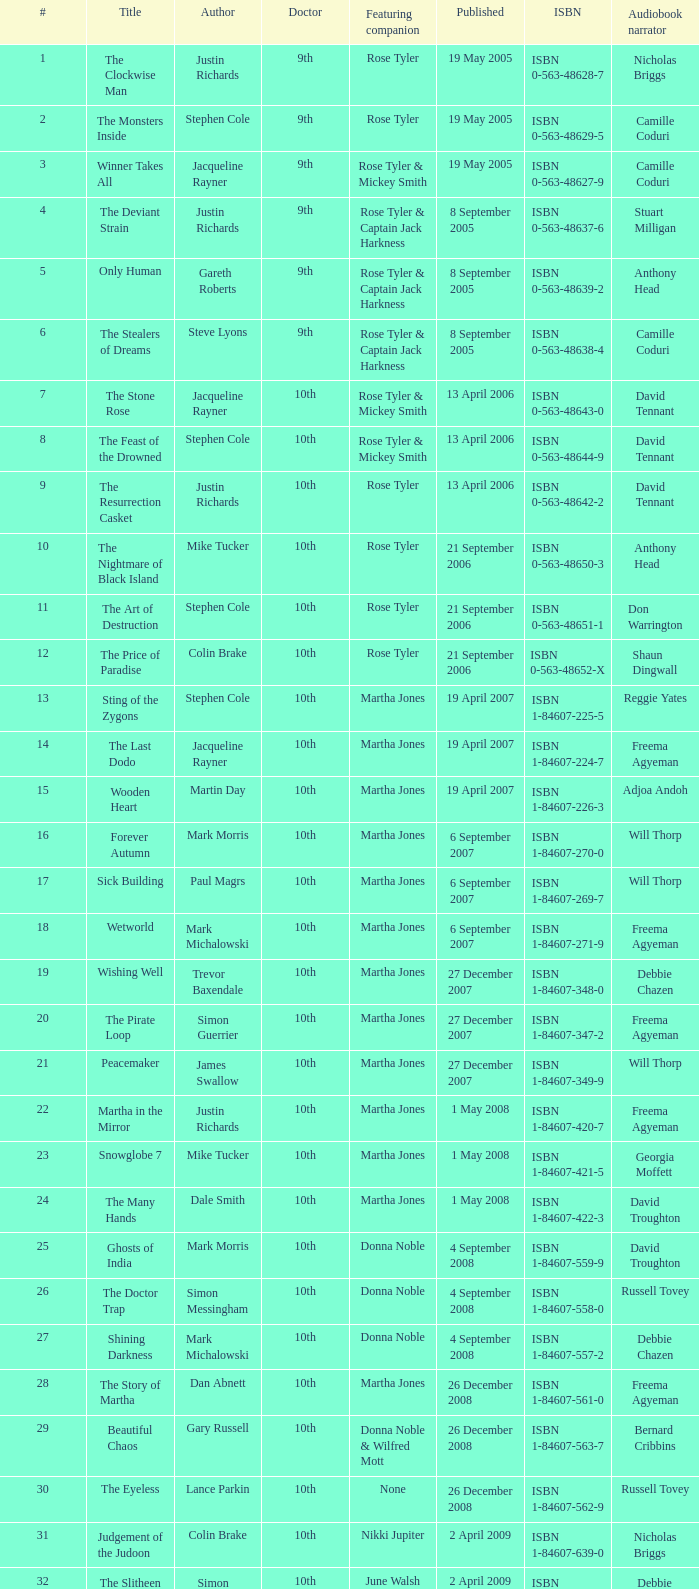What is the name of the 8th book? The Feast of the Drowned. 